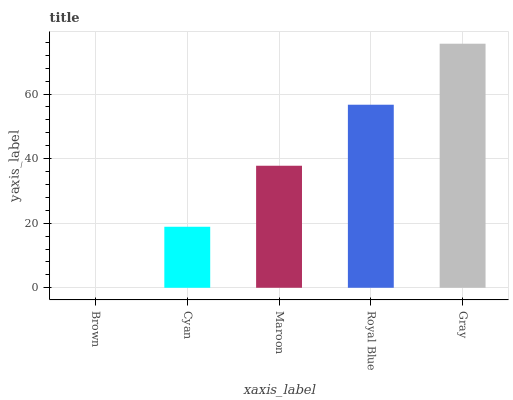Is Brown the minimum?
Answer yes or no. Yes. Is Gray the maximum?
Answer yes or no. Yes. Is Cyan the minimum?
Answer yes or no. No. Is Cyan the maximum?
Answer yes or no. No. Is Cyan greater than Brown?
Answer yes or no. Yes. Is Brown less than Cyan?
Answer yes or no. Yes. Is Brown greater than Cyan?
Answer yes or no. No. Is Cyan less than Brown?
Answer yes or no. No. Is Maroon the high median?
Answer yes or no. Yes. Is Maroon the low median?
Answer yes or no. Yes. Is Gray the high median?
Answer yes or no. No. Is Gray the low median?
Answer yes or no. No. 